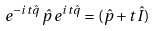<formula> <loc_0><loc_0><loc_500><loc_500>e ^ { - i t \hat { q } } \, \hat { p } \, e ^ { i t \hat { q } } = ( \hat { p } + t \hat { I } )</formula> 